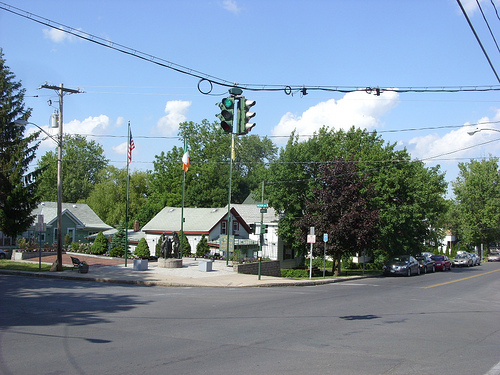Can you tell me more about the memorial shown in the image? The image features a modest memorial with an American flag and a POW/MIA flag, indicating it's dedicated to veterans. Typically, such memorials honor local military service members who served their country. 